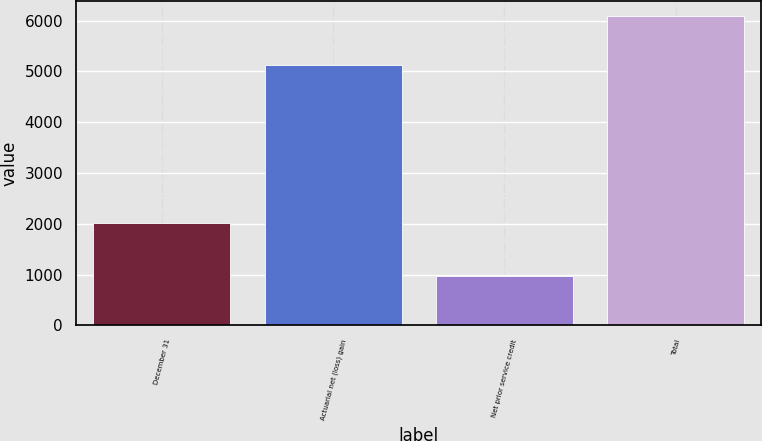<chart> <loc_0><loc_0><loc_500><loc_500><bar_chart><fcel>December 31<fcel>Actuarial net (loss) gain<fcel>Net prior service credit<fcel>Total<nl><fcel>2010<fcel>5118<fcel>973<fcel>6091<nl></chart> 